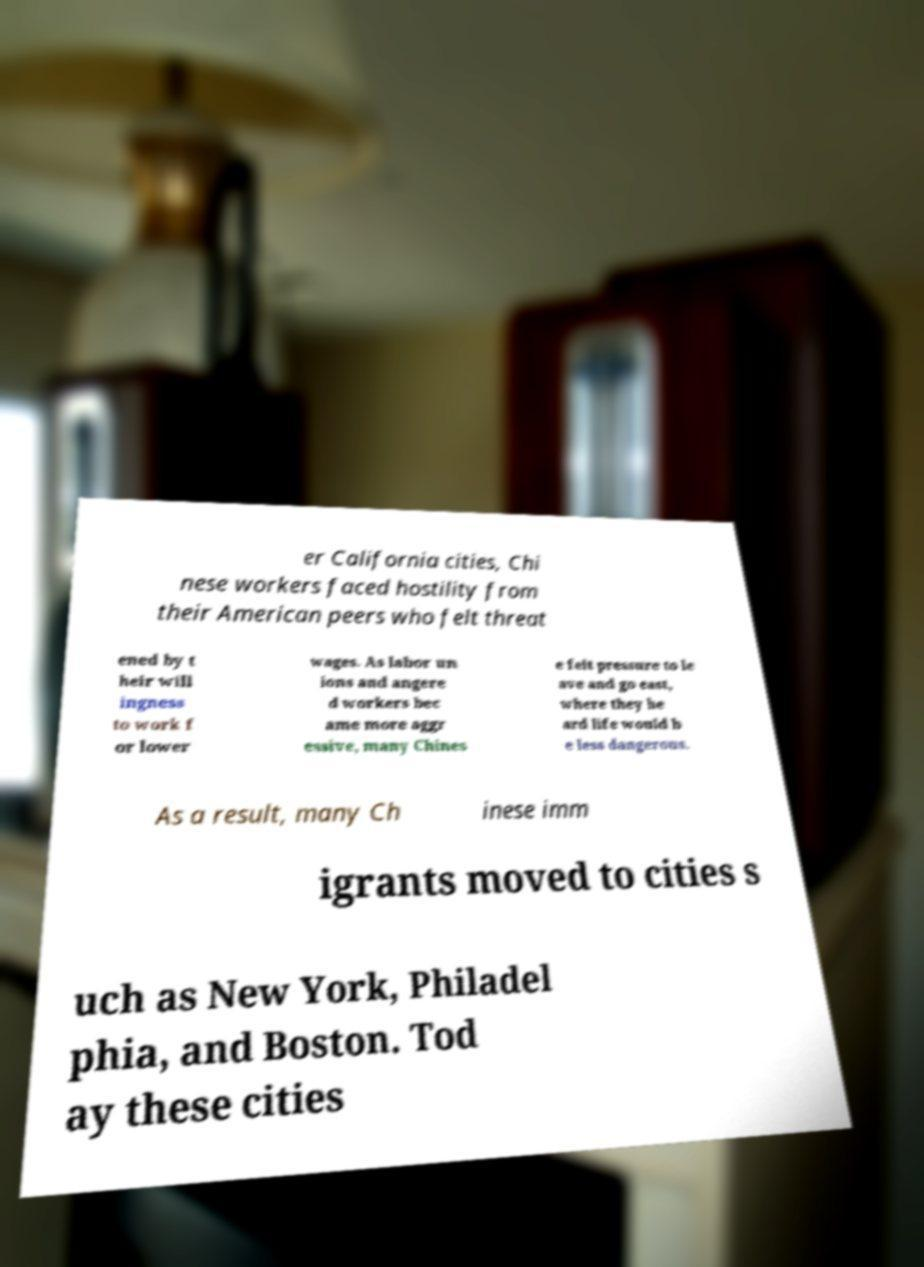What messages or text are displayed in this image? I need them in a readable, typed format. er California cities, Chi nese workers faced hostility from their American peers who felt threat ened by t heir will ingness to work f or lower wages. As labor un ions and angere d workers bec ame more aggr essive, many Chines e felt pressure to le ave and go east, where they he ard life would b e less dangerous. As a result, many Ch inese imm igrants moved to cities s uch as New York, Philadel phia, and Boston. Tod ay these cities 